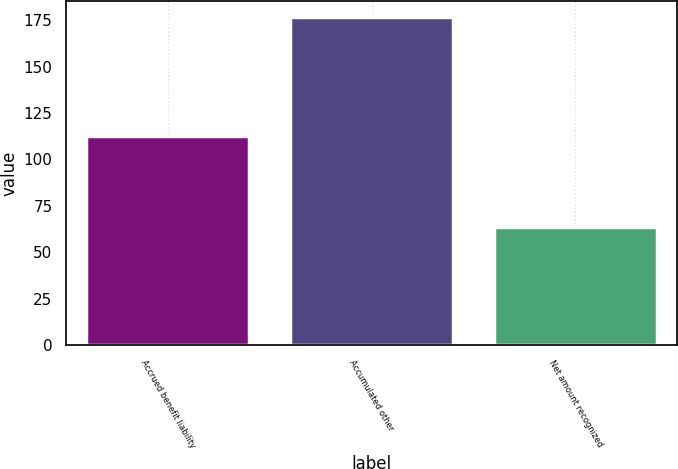<chart> <loc_0><loc_0><loc_500><loc_500><bar_chart><fcel>Accrued benefit liability<fcel>Accumulated other<fcel>Net amount recognized<nl><fcel>112.8<fcel>176.5<fcel>63.7<nl></chart> 